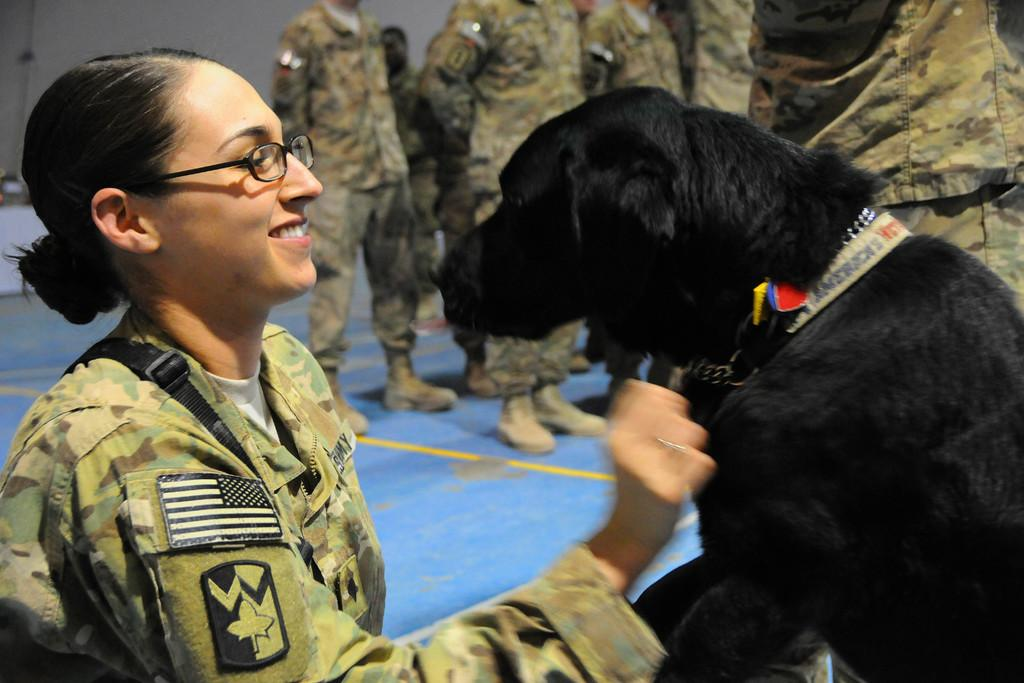Who is the main subject in the image? There is a woman in the image. What is the woman holding in the image? The woman is holding a dog. Where are the woman and the dog located in the image? The woman and the dog are at the bottom of the image. What can be seen in the background of the image? There are people in the background of the image. What grade of winter is depicted in the image? There is no indication of winter or any grade in the image; it features a woman holding a dog at the bottom of the image with people in the background. 